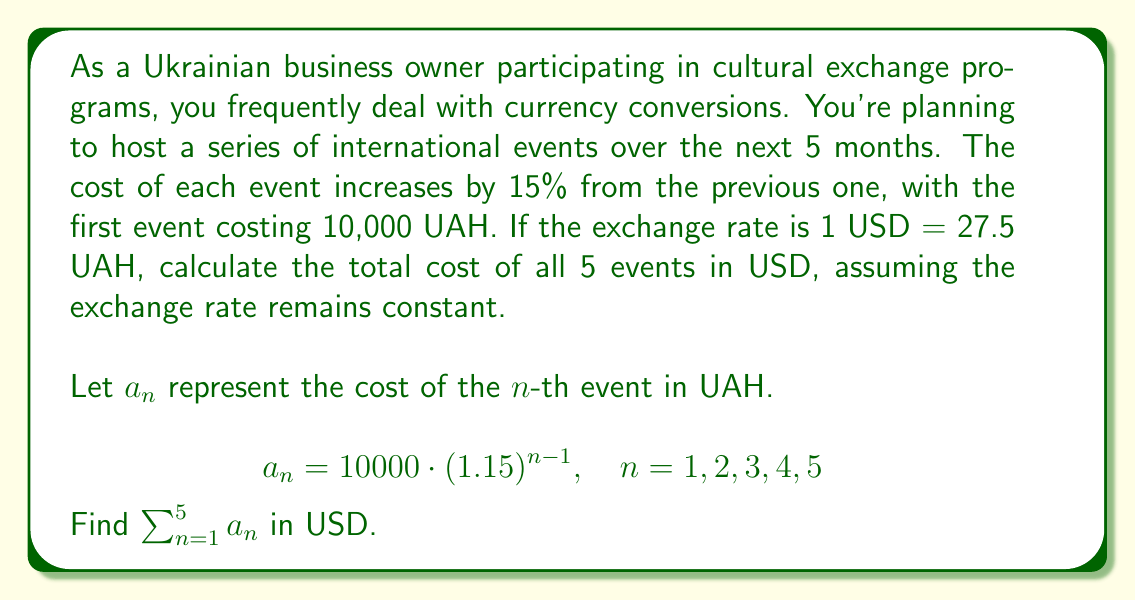Help me with this question. To solve this problem, we'll follow these steps:

1. Recognize that this is a geometric sequence with $a_1 = 10000$ and common ratio $r = 1.15$.

2. Use the formula for the sum of a geometric series:
   $$S_n = \frac{a_1(1-r^n)}{1-r}, \quad \text{where } r \neq 1$$

3. Substitute the values:
   $$S_5 = \frac{10000(1-1.15^5)}{1-1.15}$$

4. Calculate:
   $$S_5 = \frac{10000(1-2.011357421875)}{-0.15}$$
   $$S_5 = \frac{10000(-1.011357421875)}{-0.15}$$
   $$S_5 = 67423.8281250 \text{ UAH}$$

5. Convert to USD:
   $$\text{Total in USD} = \frac{67423.8281250}{27.5}$$

6. Round to two decimal places for currency:
   $$\text{Total in USD} = 2451.77$$
Answer: $2451.77 USD 